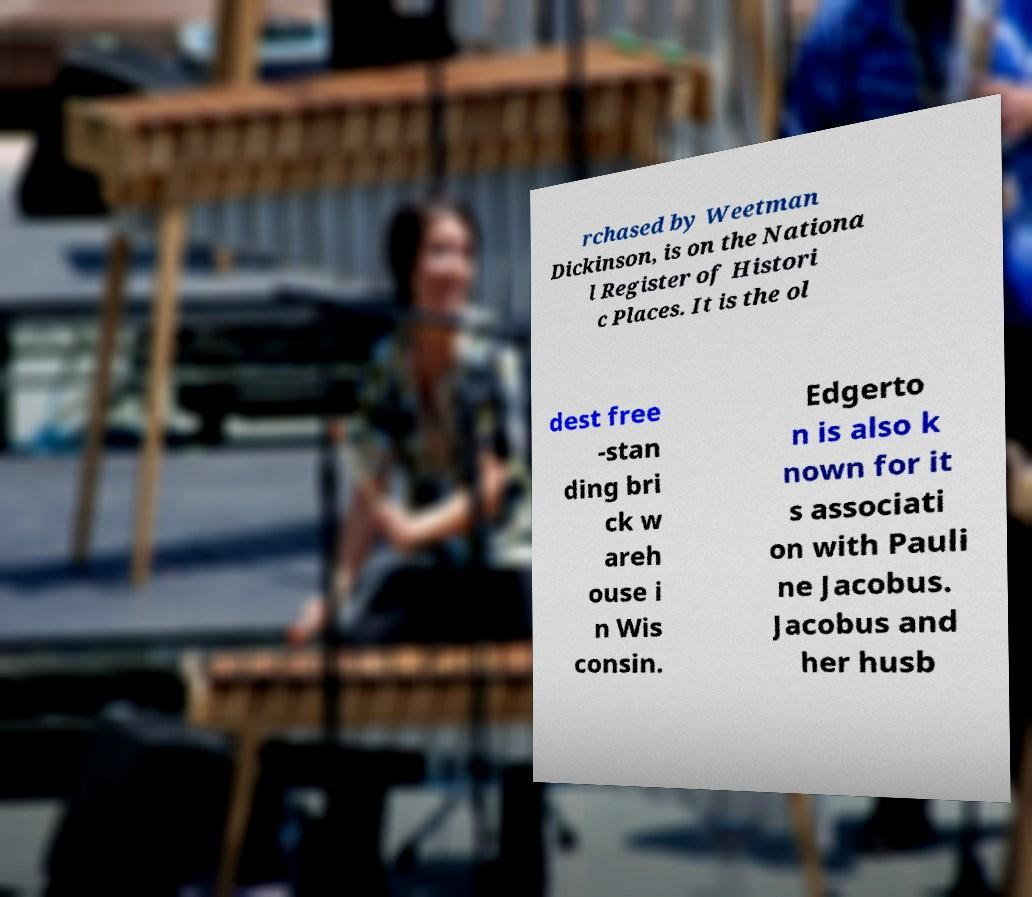Please identify and transcribe the text found in this image. rchased by Weetman Dickinson, is on the Nationa l Register of Histori c Places. It is the ol dest free -stan ding bri ck w areh ouse i n Wis consin. Edgerto n is also k nown for it s associati on with Pauli ne Jacobus. Jacobus and her husb 